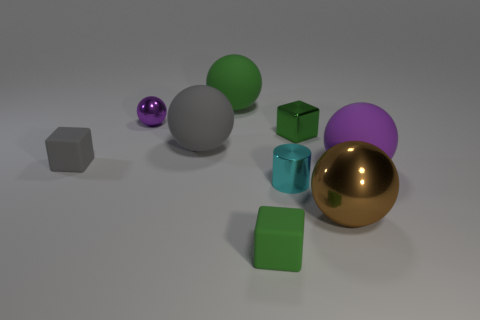What is the shape of the purple shiny thing? sphere 